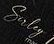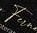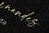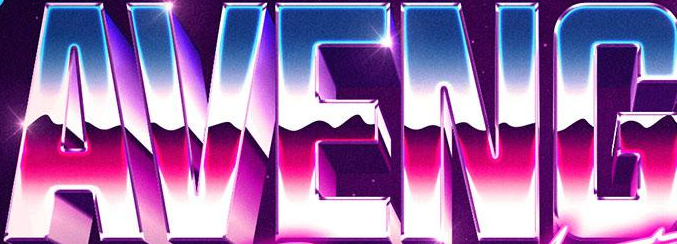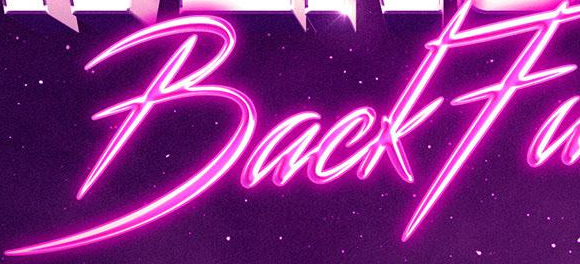Read the text from these images in sequence, separated by a semicolon. Suley; Fu; #####; AVENG; BackFa 